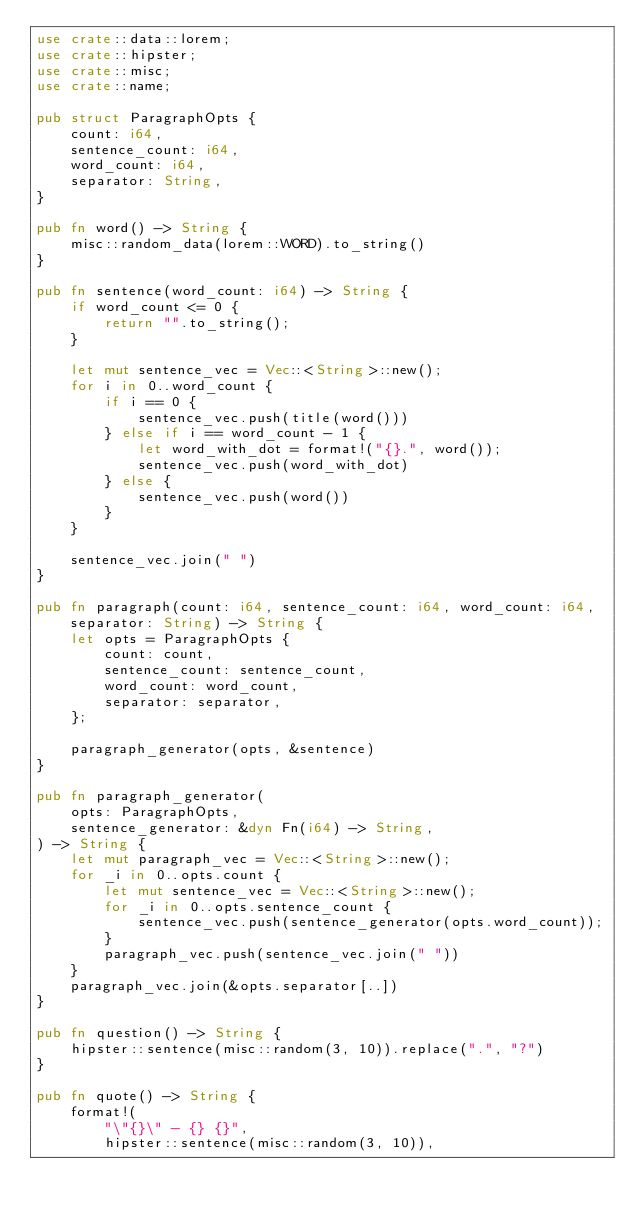<code> <loc_0><loc_0><loc_500><loc_500><_Rust_>use crate::data::lorem;
use crate::hipster;
use crate::misc;
use crate::name;

pub struct ParagraphOpts {
    count: i64,
    sentence_count: i64,
    word_count: i64,
    separator: String,
}

pub fn word() -> String {
    misc::random_data(lorem::WORD).to_string()
}

pub fn sentence(word_count: i64) -> String {
    if word_count <= 0 {
        return "".to_string();
    }

    let mut sentence_vec = Vec::<String>::new();
    for i in 0..word_count {
        if i == 0 {
            sentence_vec.push(title(word()))
        } else if i == word_count - 1 {
            let word_with_dot = format!("{}.", word());
            sentence_vec.push(word_with_dot)
        } else {
            sentence_vec.push(word())
        }
    }

    sentence_vec.join(" ")
}

pub fn paragraph(count: i64, sentence_count: i64, word_count: i64, separator: String) -> String {
    let opts = ParagraphOpts {
        count: count,
        sentence_count: sentence_count,
        word_count: word_count,
        separator: separator,
    };

    paragraph_generator(opts, &sentence)
}

pub fn paragraph_generator(
    opts: ParagraphOpts,
    sentence_generator: &dyn Fn(i64) -> String,
) -> String {
    let mut paragraph_vec = Vec::<String>::new();
    for _i in 0..opts.count {
        let mut sentence_vec = Vec::<String>::new();
        for _i in 0..opts.sentence_count {
            sentence_vec.push(sentence_generator(opts.word_count));
        }
        paragraph_vec.push(sentence_vec.join(" "))
    }
    paragraph_vec.join(&opts.separator[..])
}

pub fn question() -> String {
    hipster::sentence(misc::random(3, 10)).replace(".", "?")
}

pub fn quote() -> String {
    format!(
        "\"{}\" - {} {}",
        hipster::sentence(misc::random(3, 10)),</code> 